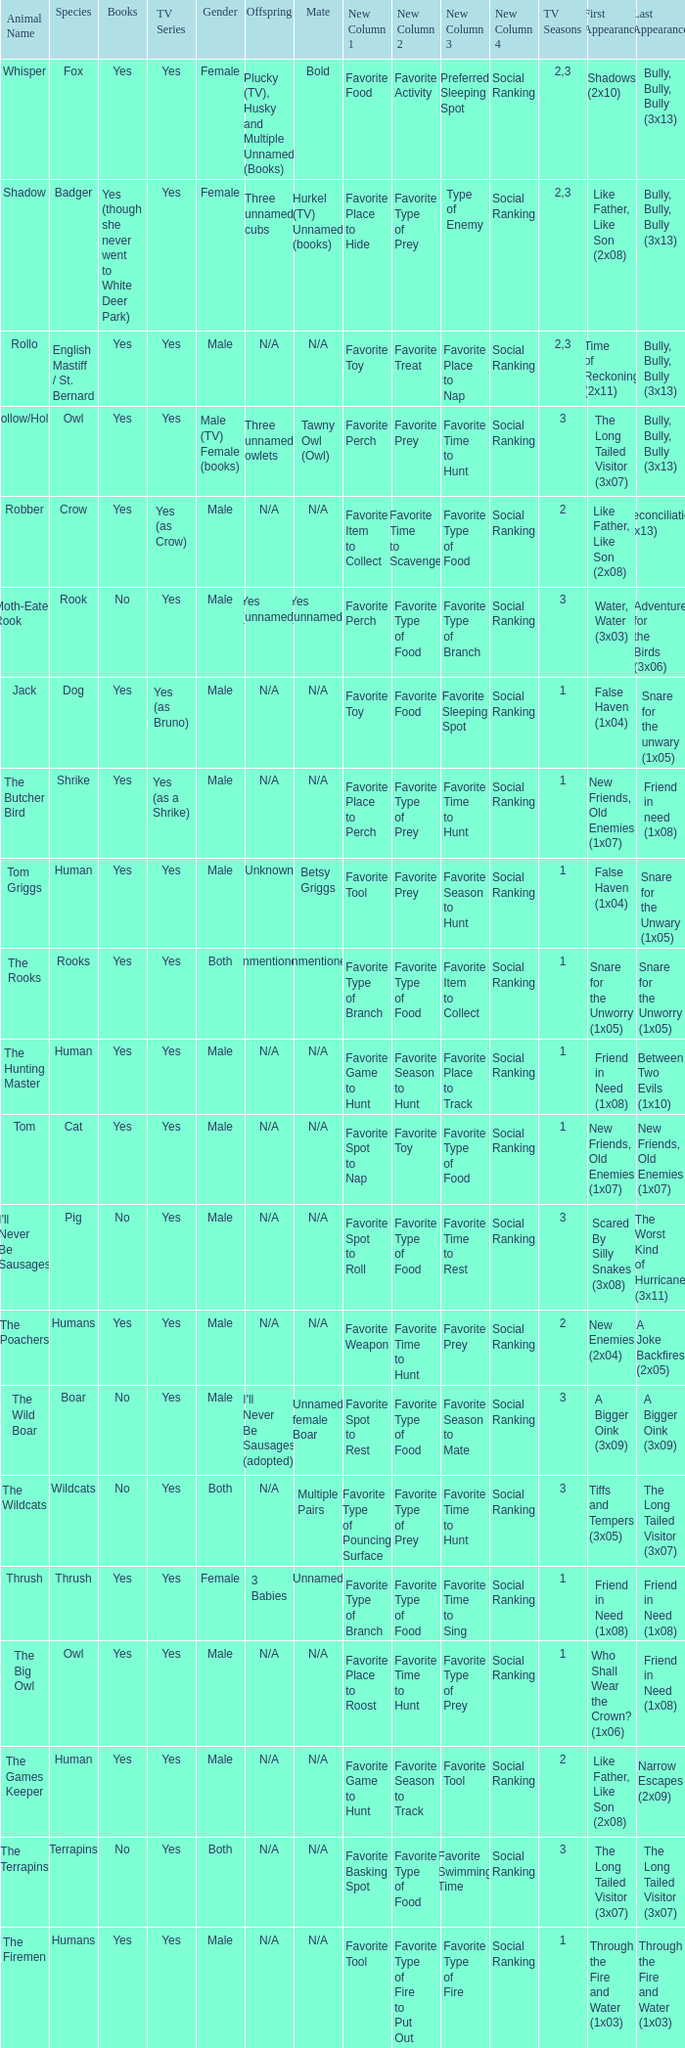What show has a boar? Yes. 